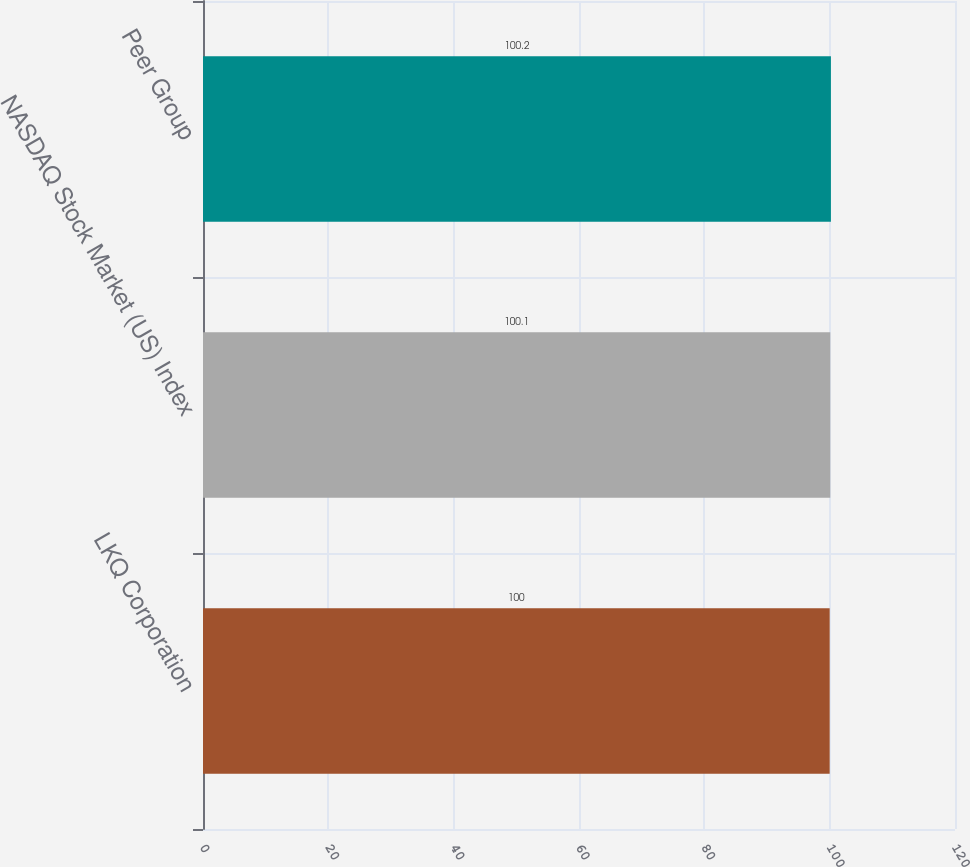Convert chart to OTSL. <chart><loc_0><loc_0><loc_500><loc_500><bar_chart><fcel>LKQ Corporation<fcel>NASDAQ Stock Market (US) Index<fcel>Peer Group<nl><fcel>100<fcel>100.1<fcel>100.2<nl></chart> 